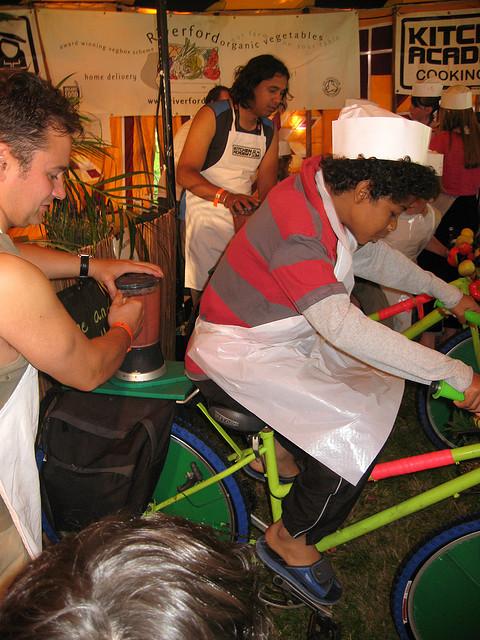Is this a party?
Write a very short answer. No. What is the person riding?
Answer briefly. Bike. Does this picture involve cooking?
Answer briefly. No. 